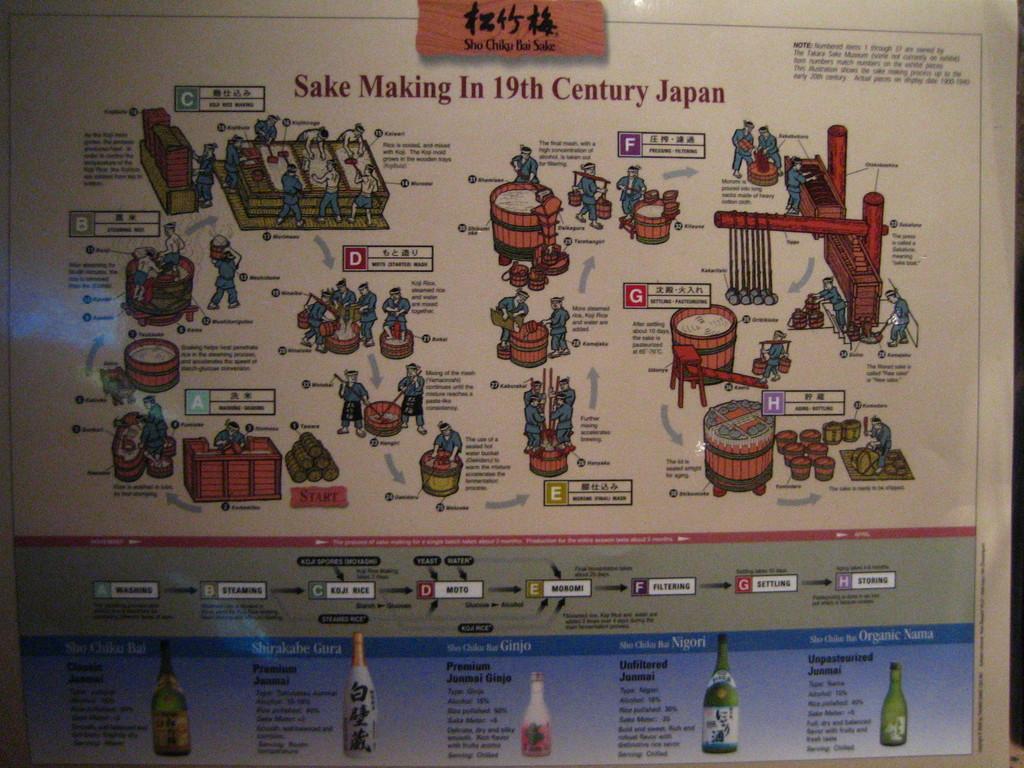How many steps where there in making sake in 19th century japan?
Offer a very short reply. 8. What does this image show a history of?
Make the answer very short. Sake making. 